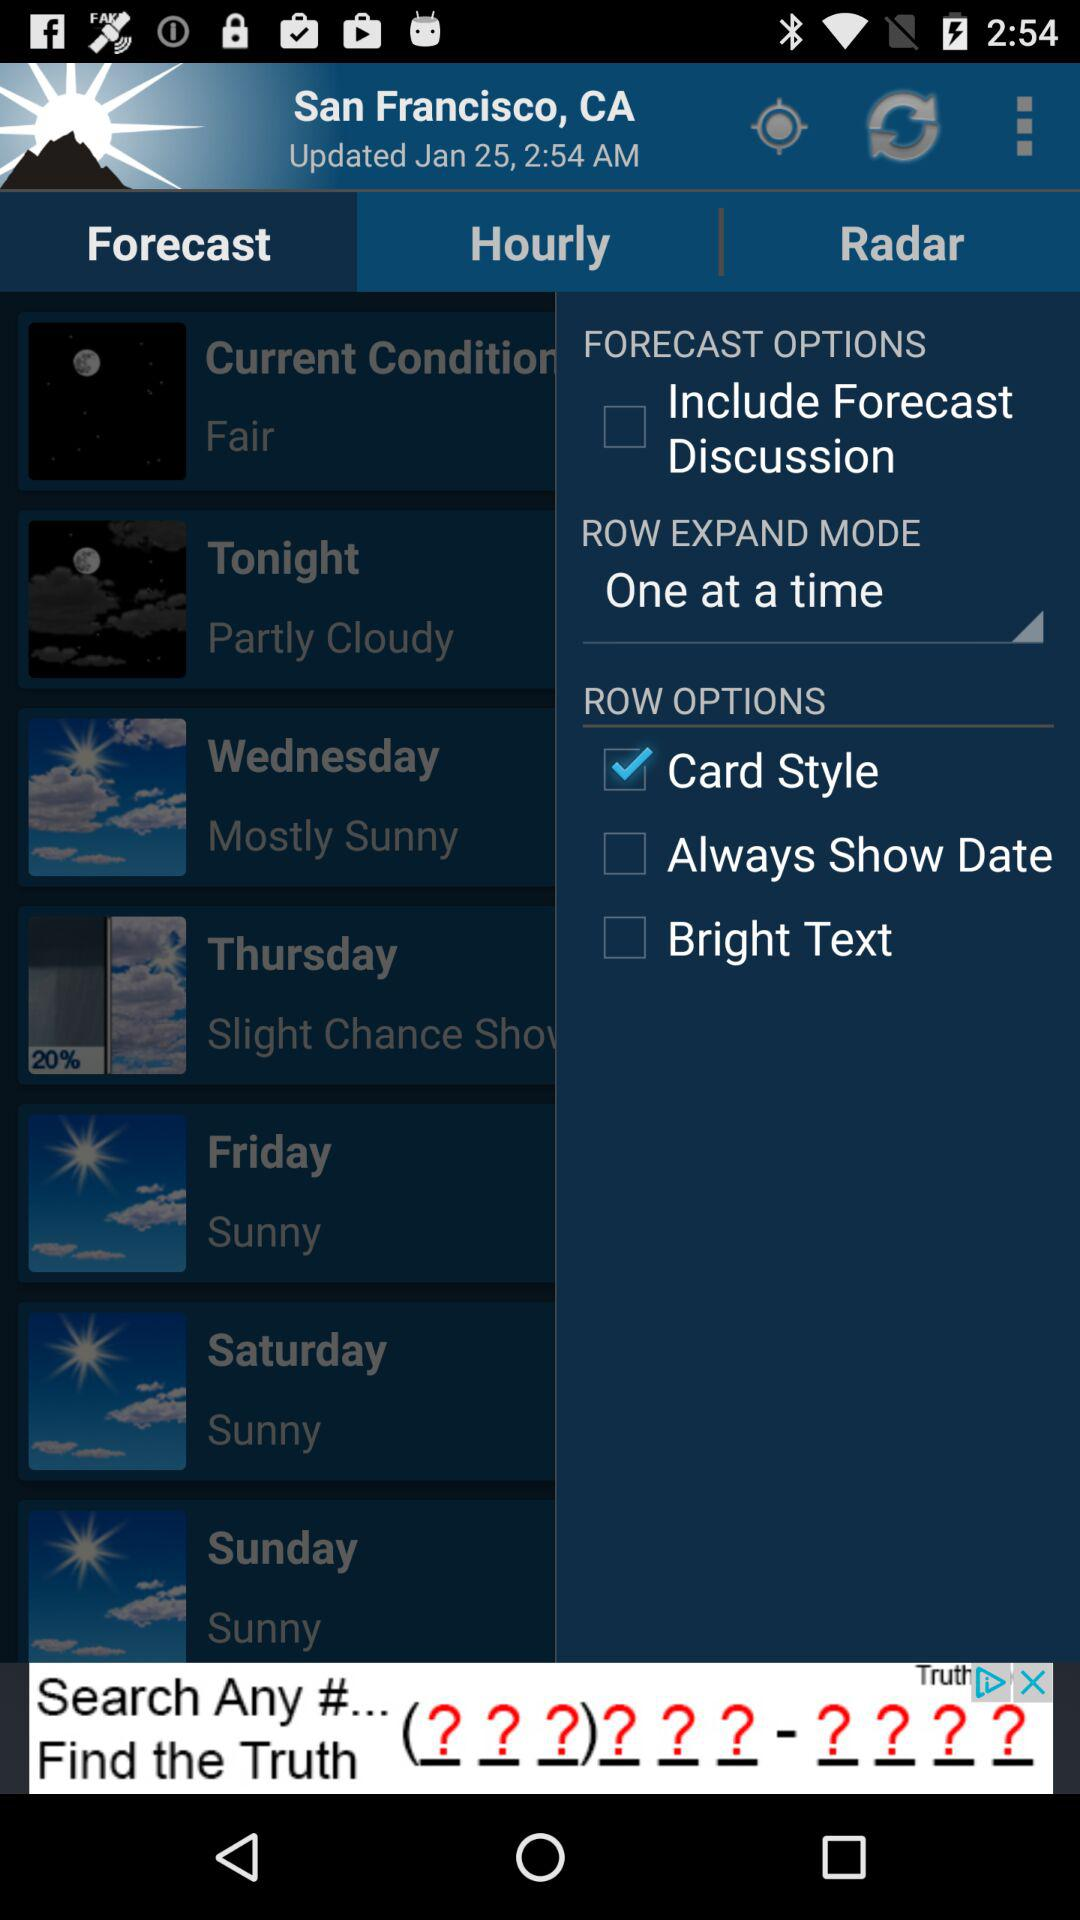What is the setting for "ROW EXPAND MODE"? The setting is "One at a time". 